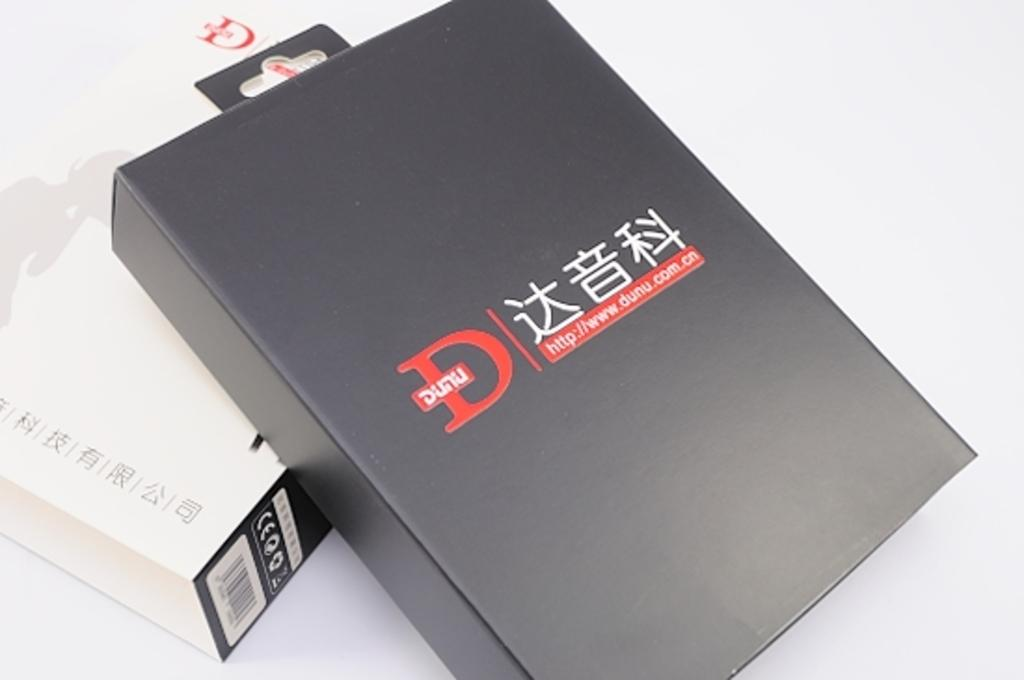<image>
Summarize the visual content of the image. A black box with a hanging tag and a dunu.com website on it. 